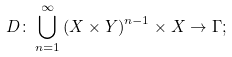<formula> <loc_0><loc_0><loc_500><loc_500>D \colon \bigcup _ { n = 1 } ^ { \infty } \left ( X \times Y \right ) ^ { n - 1 } \times X \to \Gamma ;</formula> 